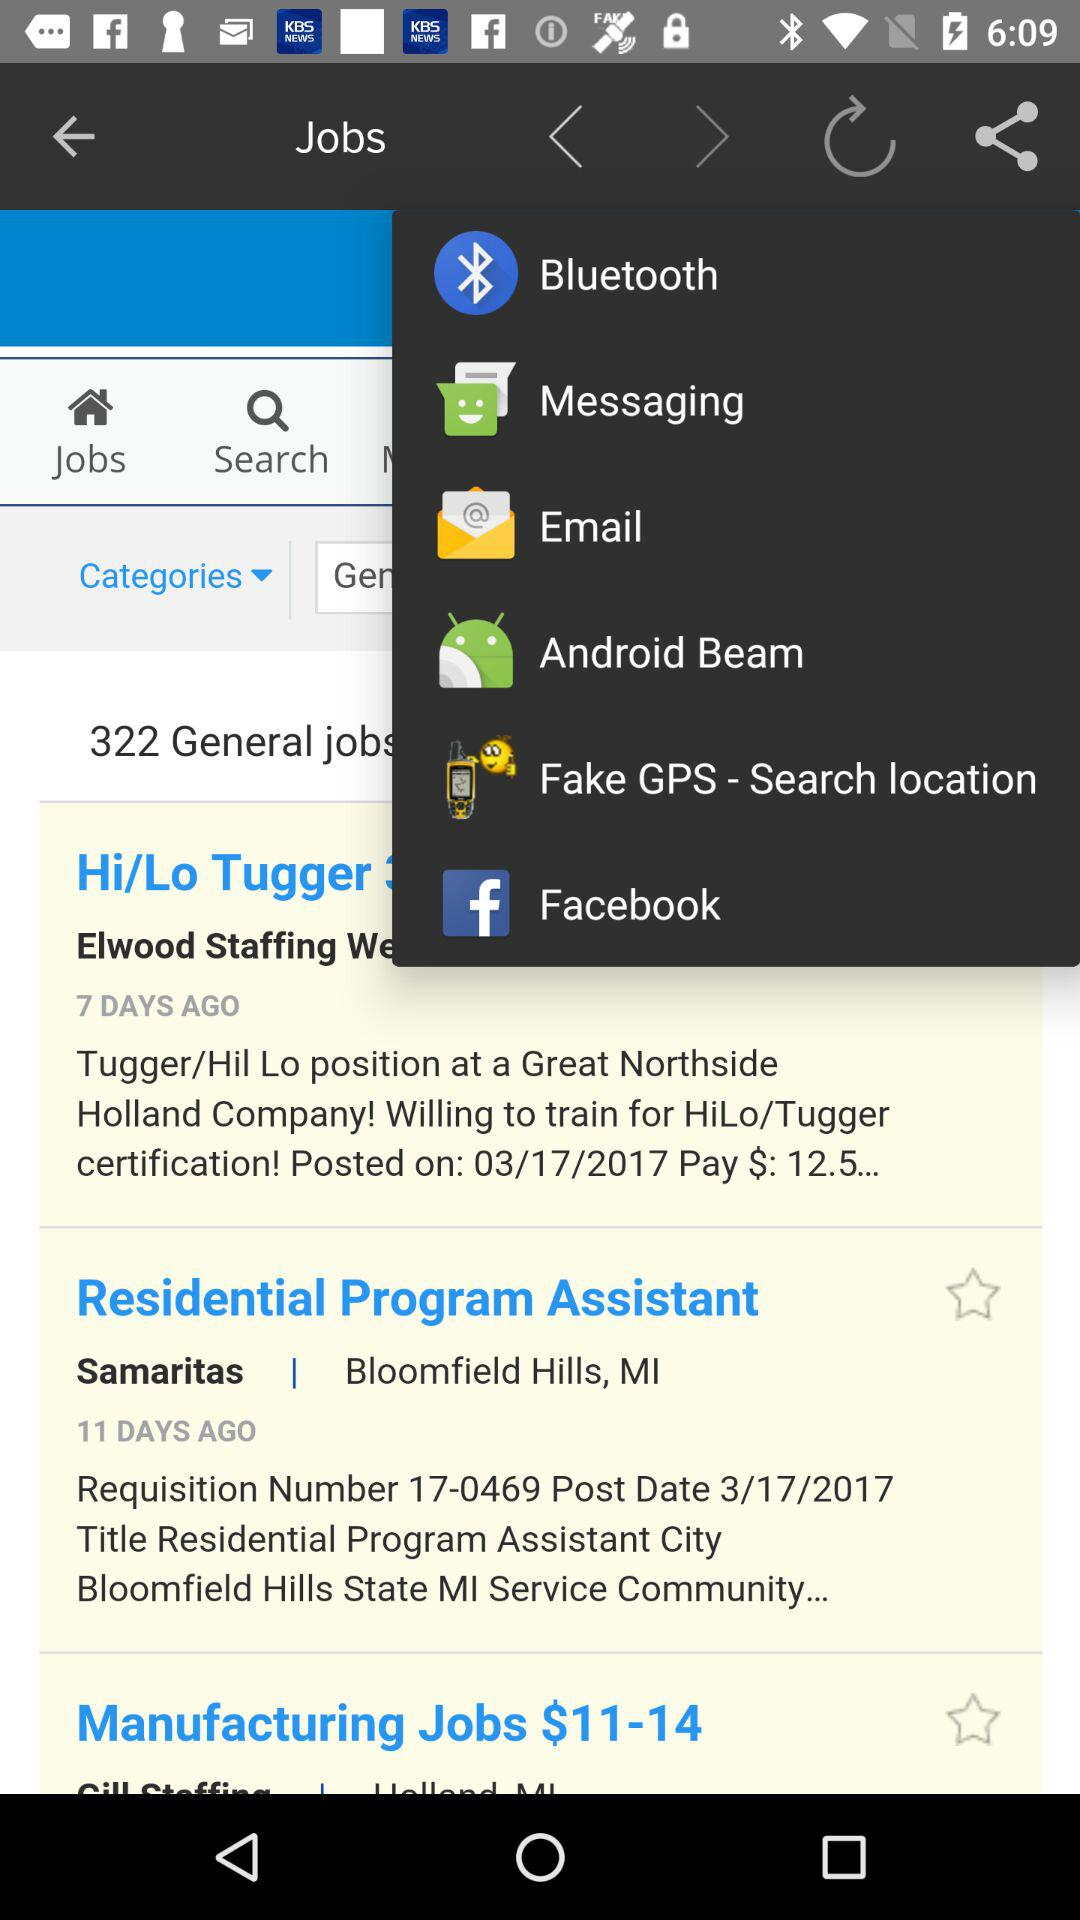Which tab is selected?
When the provided information is insufficient, respond with <no answer>. <no answer> 